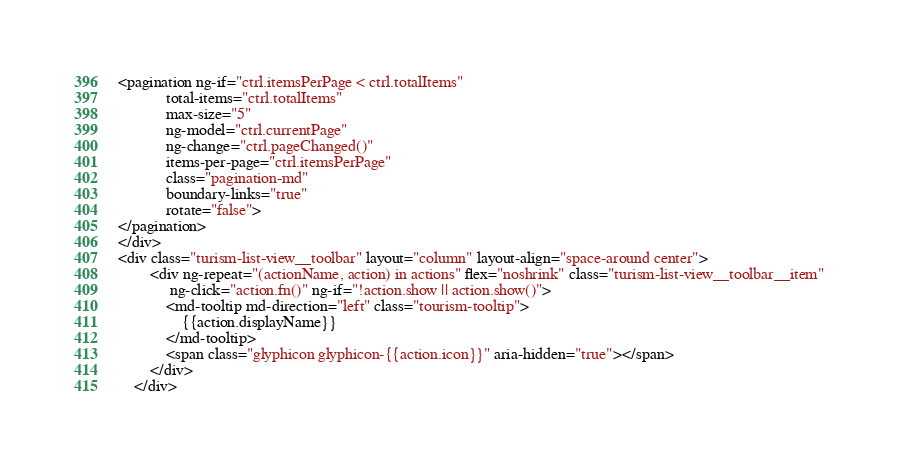Convert code to text. <code><loc_0><loc_0><loc_500><loc_500><_HTML_><pagination ng-if="ctrl.itemsPerPage < ctrl.totalItems"
            total-items="ctrl.totalItems"
            max-size="5"
            ng-model="ctrl.currentPage"
            ng-change="ctrl.pageChanged()"
            items-per-page="ctrl.itemsPerPage"
            class="pagination-md" 
            boundary-links="true" 
            rotate="false">
</pagination>
</div>
<div class="turism-list-view__toolbar" layout="column" layout-align="space-around center">
        <div ng-repeat="(actionName, action) in actions" flex="noshrink" class="turism-list-view__toolbar__item"
             ng-click="action.fn()" ng-if="!action.show || action.show()">
            <md-tooltip md-direction="left" class="tourism-tooltip">
                {{action.displayName}}
            </md-tooltip>
            <span class="glyphicon glyphicon-{{action.icon}}" aria-hidden="true"></span>
        </div>
    </div></code> 